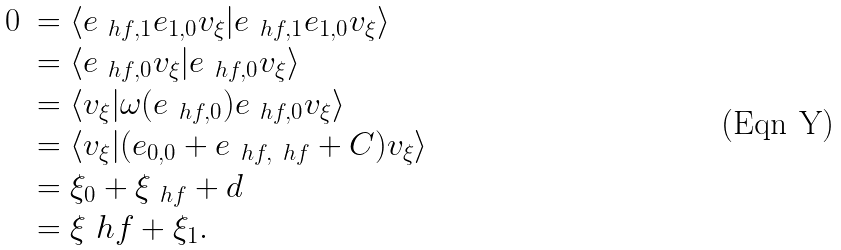<formula> <loc_0><loc_0><loc_500><loc_500>\begin{array} { l l } 0 & = \langle e _ { \ h f , 1 } e _ { 1 , 0 } v _ { \xi } | e _ { \ h f , 1 } e _ { 1 , 0 } v _ { \xi } \rangle \\ & = \langle e _ { \ h f , 0 } v _ { \xi } | e _ { \ h f , 0 } v _ { \xi } \rangle \\ & = \langle v _ { \xi } | \omega ( e _ { \ h f , 0 } ) e _ { \ h f , 0 } v _ { \xi } \rangle \\ & = \langle v _ { \xi } | ( e _ { 0 , 0 } + e _ { \ h f , \ h f } + C ) v _ { \xi } \rangle \\ & = \xi _ { 0 } + \xi _ { \ h f } + d \\ & = \xi _ { \ } h f + \xi _ { 1 } . \\ \end{array}</formula> 